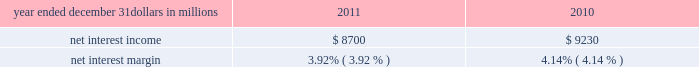Corporate & institutional banking corporate & institutional banking earned $ 1.9 billion in 2011 and $ 1.8 billion in 2010 .
The increase in earnings was primarily due to an improvement in the provision for credit losses , which was a benefit in 2011 , partially offset by a reduction in the value of commercial mortgage servicing rights and lower net interest income .
We continued to focus on adding new clients , increasing cross sales , and remaining committed to strong expense discipline .
Asset management group asset management group earned $ 141 million for 2011 compared with $ 137 million for 2010 .
Assets under administration were $ 210 billion at december 31 , 2011 and $ 212 billion at december 31 , 2010 .
Earnings for 2011 reflected a benefit from the provision for credit losses and growth in noninterest income , partially offset by higher noninterest expense and lower net interest income .
For 2011 , the business delivered strong sales production , grew high value clients and benefitted from significant referrals from other pnc lines of business .
Over time and with stabilized market conditions , the successful execution of these strategies and the accumulation of our strong sales performance are expected to create meaningful growth in assets under management and noninterest income .
Residential mortgage banking residential mortgage banking earned $ 87 million in 2011 compared with $ 269 million in 2010 .
The decline in earnings was driven by an increase in noninterest expense associated with increased costs for residential mortgage foreclosure- related expenses , primarily as a result of ongoing governmental matters , and lower net interest income , partially offset by an increase in loan originations and higher loans sales revenue .
Blackrock our blackrock business segment earned $ 361 million in 2011 and $ 351 million in 2010 .
The higher business segment earnings from blackrock for 2011 compared with 2010 were primarily due to an increase in revenue .
Non-strategic assets portfolio this business segment ( formerly distressed assets portfolio ) consists primarily of acquired non-strategic assets that fall outside of our core business strategy .
Non-strategic assets portfolio had earnings of $ 200 million in 2011 compared with a loss of $ 57 million in 2010 .
The increase was primarily attributable to a lower provision for credit losses partially offset by lower net interest income .
201cother 201d reported earnings of $ 376 million for 2011 compared with earnings of $ 386 million for 2010 .
The decrease in earnings primarily reflected the noncash charge related to the redemption of trust preferred securities in the fourth quarter of 2011 and the gain related to the sale of a portion of pnc 2019s blackrock shares in 2010 partially offset by lower integration costs in 2011 .
Consolidated income statement review our consolidated income statement is presented in item 8 of this report .
Net income for 2011 was $ 3.1 billion compared with $ 3.4 billion for 2010 .
Results for 2011 include the impact of $ 324 million of residential mortgage foreclosure-related expenses primarily as a result of ongoing governmental matters , a $ 198 million noncash charge related to redemption of trust preferred securities and $ 42 million for integration costs .
Results for 2010 included the $ 328 million after-tax gain on our sale of gis , $ 387 million for integration costs , and $ 71 million of residential mortgage foreclosure-related expenses .
For 2010 , net income attributable to common shareholders was also impacted by a noncash reduction of $ 250 million in connection with the redemption of tarp preferred stock .
Pnc 2019s results for 2011 were driven by good performance in a challenging environment of low interest rates , slow economic growth and new regulations .
Net interest income and net interest margin year ended december 31 dollars in millions 2011 2010 .
Changes in net interest income and margin result from the interaction of the volume and composition of interest-earning assets and related yields , interest-bearing liabilities and related rates paid , and noninterest-bearing sources of funding .
See the statistical information ( unaudited ) 2013 analysis of year-to-year changes in net interest income and average consolidated balance sheet and net interest analysis in item 8 and the discussion of purchase accounting accretion in the consolidated balance sheet review in item 7 of this report for additional information .
The decreases in net interest income and net interest margin for 2011 compared with 2010 were primarily attributable to a decrease in purchase accounting accretion on purchased impaired loans primarily due to lower excess cash recoveries .
A decline in average loan balances and the low interest rate environment , partially offset by lower funding costs , also contributed to the decrease .
The pnc financial services group , inc .
2013 form 10-k 35 .
For 2010 , was the after-tax gain on our sale of gis greater than overall net interest income? 
Computations: (387 > 9230)
Answer: no. 